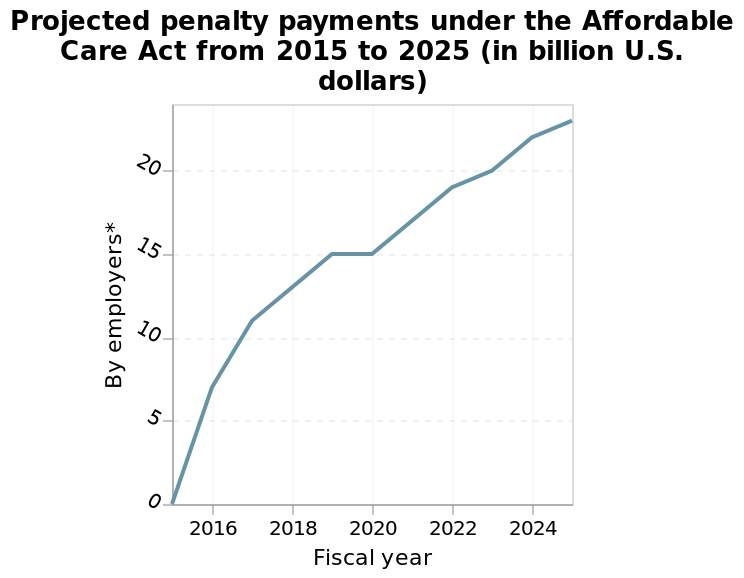<image>
Did the chart show any decrease in any year?  No, the chart only shows an increase year on year. Did the chart reach a stable level between 2019-2020?  Yes, it plateaued between years 2019-2020. 